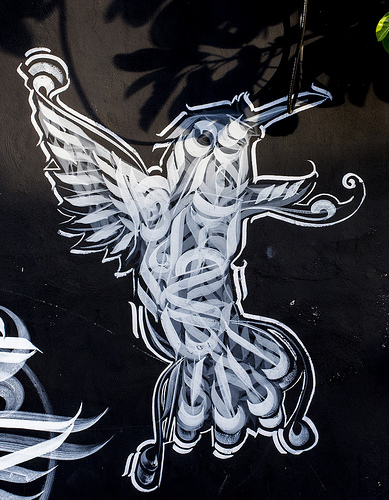<image>
Is the drawing in front of the shadow? Yes. The drawing is positioned in front of the shadow, appearing closer to the camera viewpoint. 